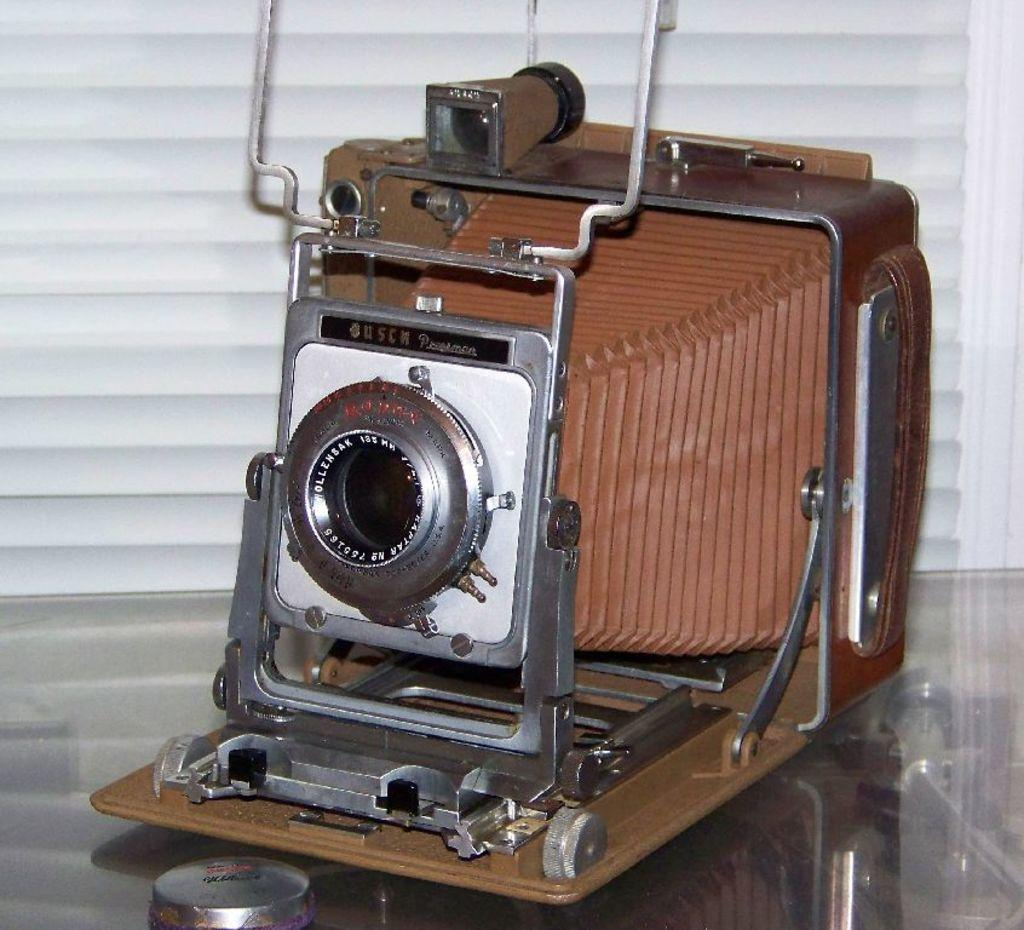What type of camera is in the image? There is a press camera in the image. What is the press camera resting on? The press camera is on a transparent glass. What can be seen behind the press camera? There is a wall visible behind the press camera. What type of record is being played on the camera in the image? There is no record being played on the camera in the image, as it is a press camera and not a device for playing records. 